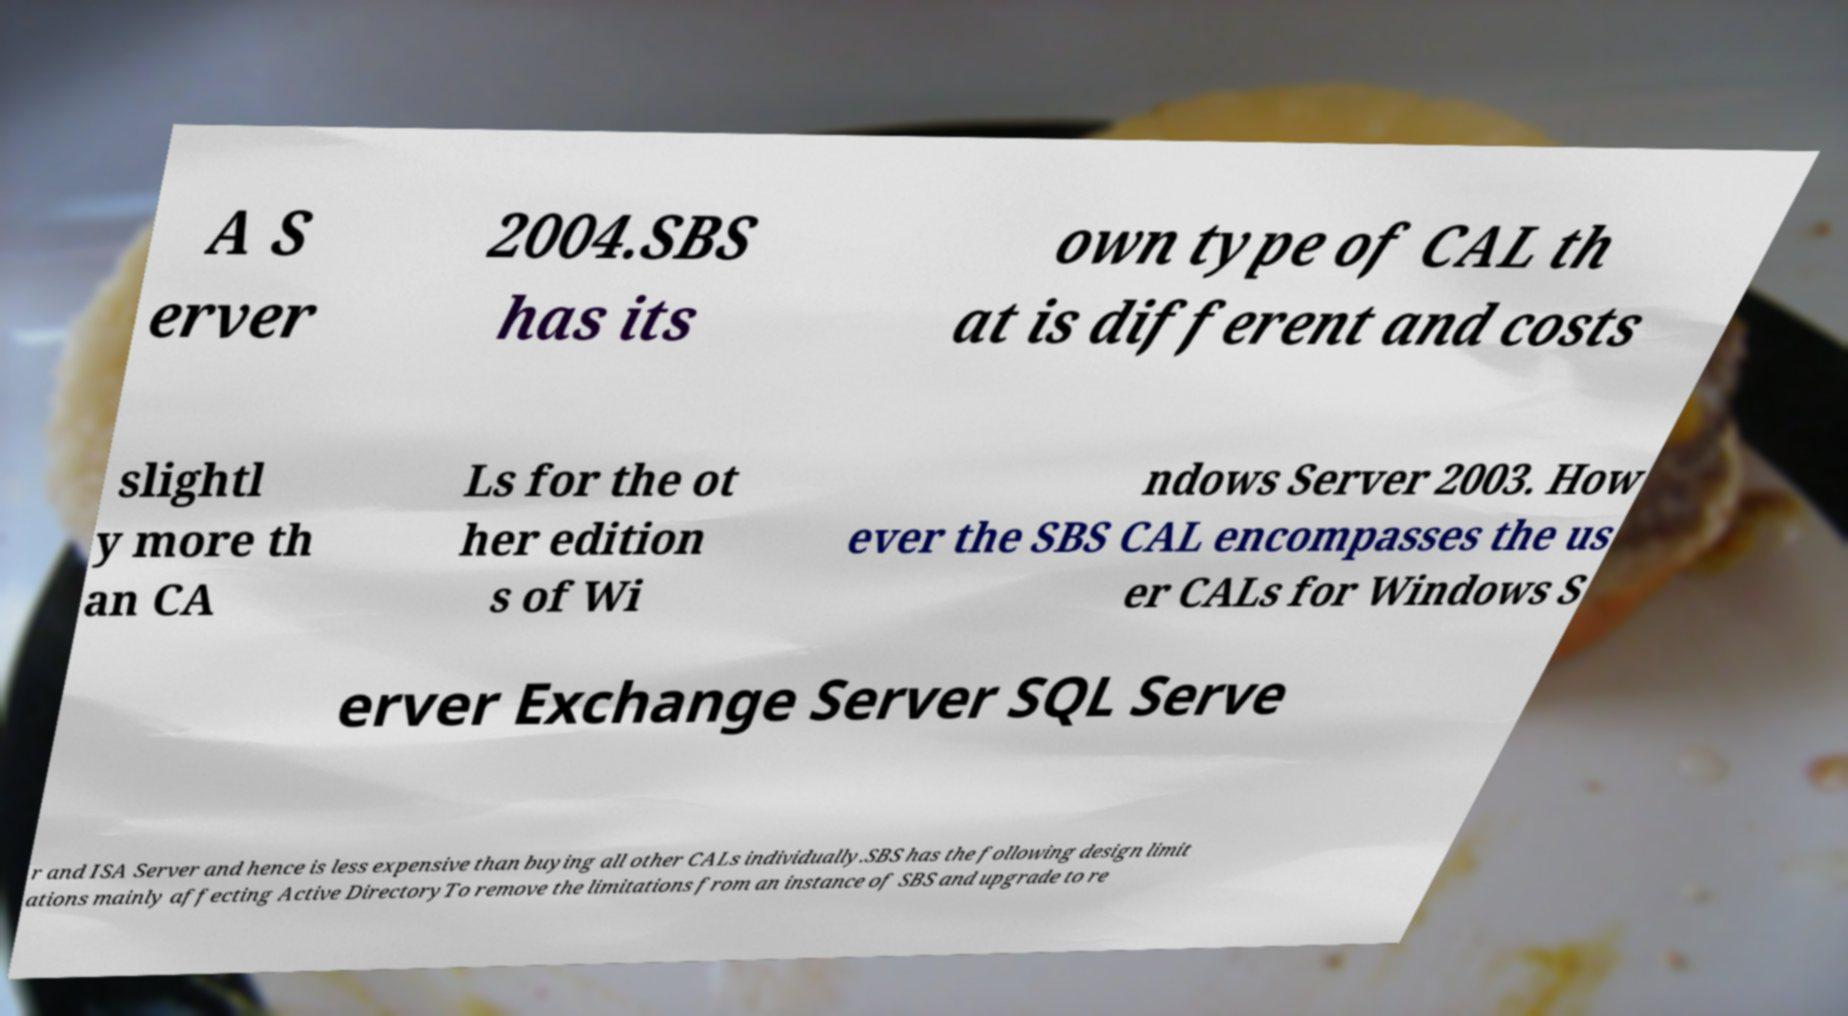Can you read and provide the text displayed in the image?This photo seems to have some interesting text. Can you extract and type it out for me? A S erver 2004.SBS has its own type of CAL th at is different and costs slightl y more th an CA Ls for the ot her edition s of Wi ndows Server 2003. How ever the SBS CAL encompasses the us er CALs for Windows S erver Exchange Server SQL Serve r and ISA Server and hence is less expensive than buying all other CALs individually.SBS has the following design limit ations mainly affecting Active DirectoryTo remove the limitations from an instance of SBS and upgrade to re 